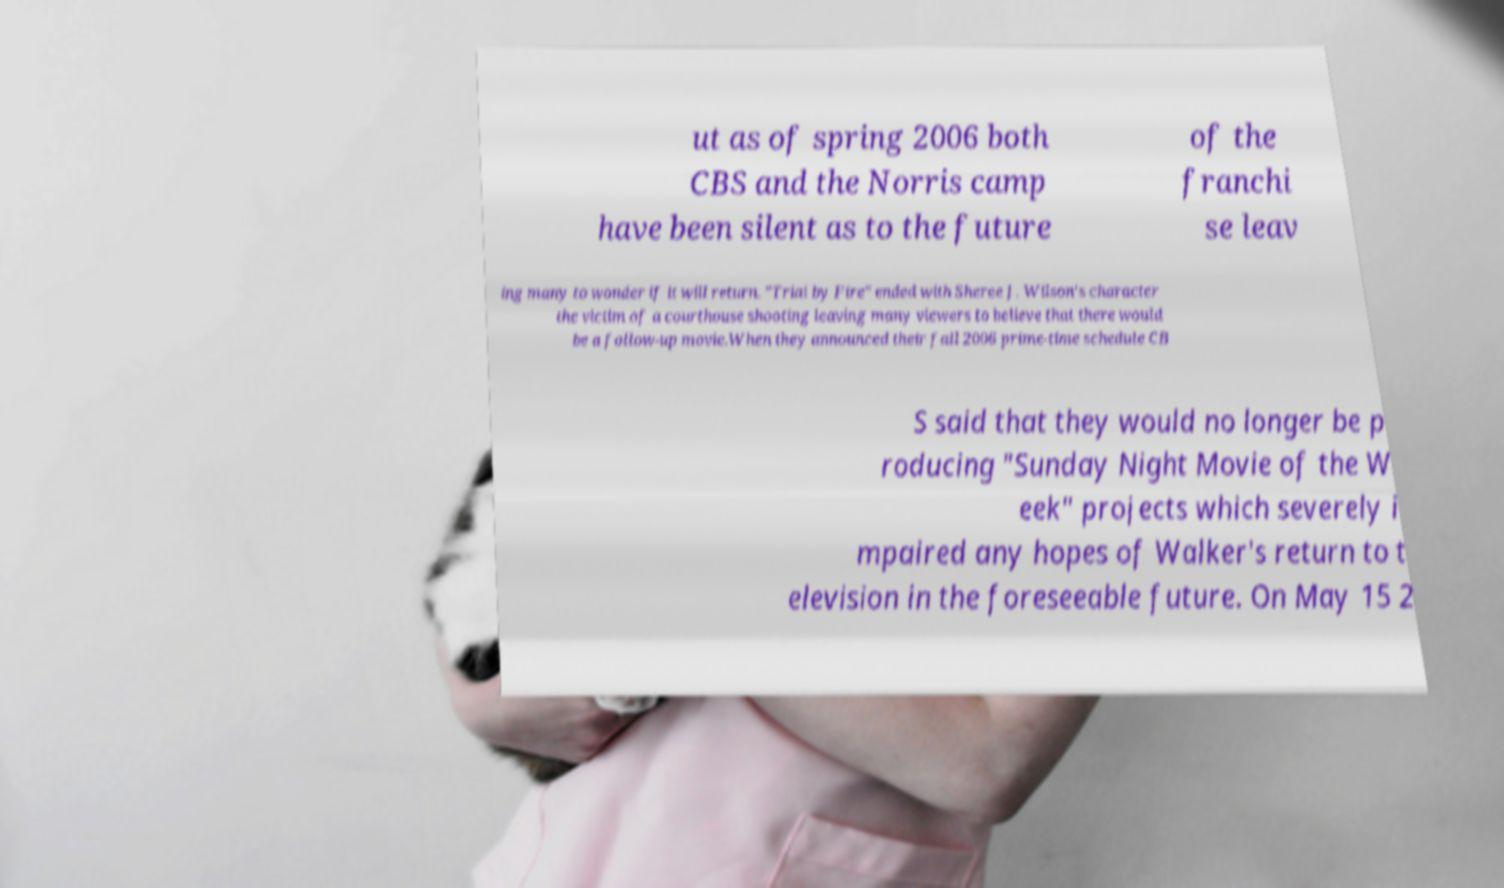There's text embedded in this image that I need extracted. Can you transcribe it verbatim? ut as of spring 2006 both CBS and the Norris camp have been silent as to the future of the franchi se leav ing many to wonder if it will return. "Trial by Fire" ended with Sheree J. Wilson's character the victim of a courthouse shooting leaving many viewers to believe that there would be a follow-up movie.When they announced their fall 2006 prime-time schedule CB S said that they would no longer be p roducing "Sunday Night Movie of the W eek" projects which severely i mpaired any hopes of Walker's return to t elevision in the foreseeable future. On May 15 2 